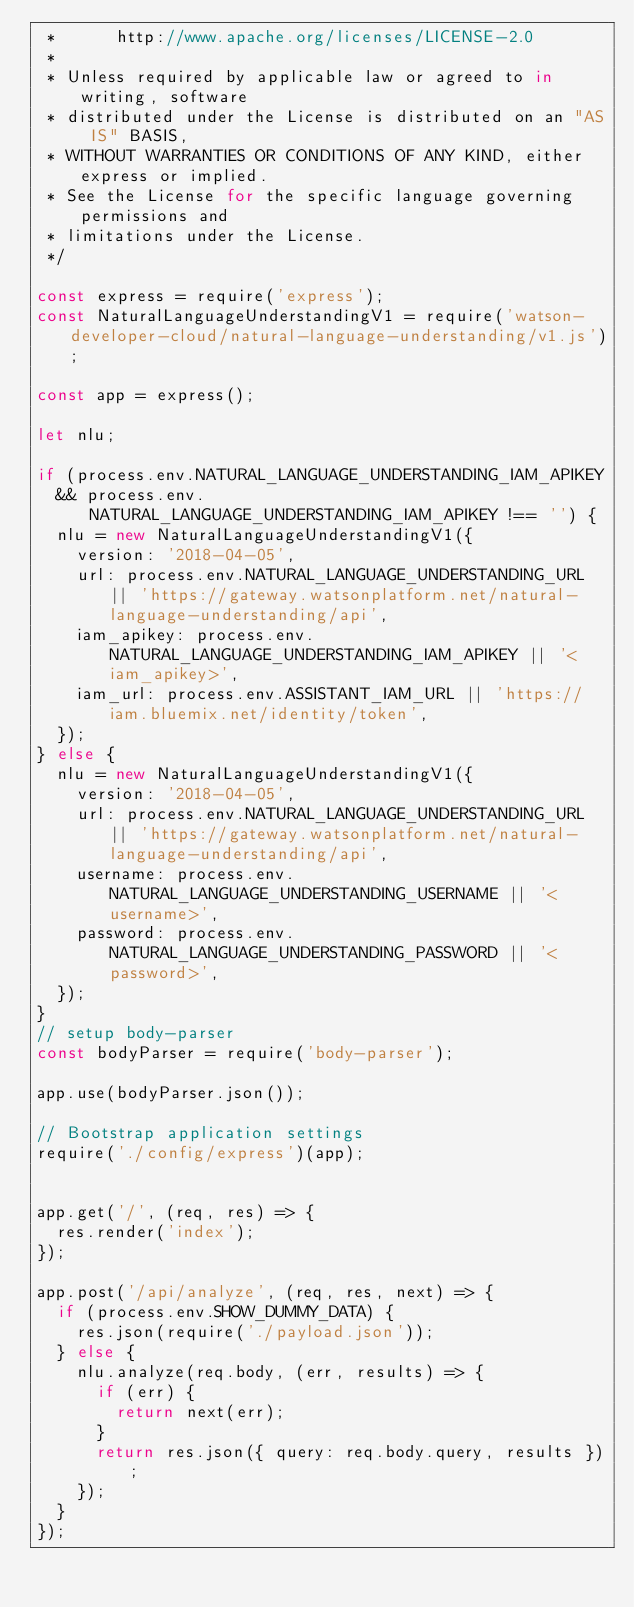Convert code to text. <code><loc_0><loc_0><loc_500><loc_500><_JavaScript_> *      http://www.apache.org/licenses/LICENSE-2.0
 *
 * Unless required by applicable law or agreed to in writing, software
 * distributed under the License is distributed on an "AS IS" BASIS,
 * WITHOUT WARRANTIES OR CONDITIONS OF ANY KIND, either express or implied.
 * See the License for the specific language governing permissions and
 * limitations under the License.
 */

const express = require('express');
const NaturalLanguageUnderstandingV1 = require('watson-developer-cloud/natural-language-understanding/v1.js');

const app = express();

let nlu;

if (process.env.NATURAL_LANGUAGE_UNDERSTANDING_IAM_APIKEY
  && process.env.NATURAL_LANGUAGE_UNDERSTANDING_IAM_APIKEY !== '') {
  nlu = new NaturalLanguageUnderstandingV1({
    version: '2018-04-05',
    url: process.env.NATURAL_LANGUAGE_UNDERSTANDING_URL || 'https://gateway.watsonplatform.net/natural-language-understanding/api',
    iam_apikey: process.env.NATURAL_LANGUAGE_UNDERSTANDING_IAM_APIKEY || '<iam_apikey>',
    iam_url: process.env.ASSISTANT_IAM_URL || 'https://iam.bluemix.net/identity/token',
  });
} else {
  nlu = new NaturalLanguageUnderstandingV1({
    version: '2018-04-05',
    url: process.env.NATURAL_LANGUAGE_UNDERSTANDING_URL || 'https://gateway.watsonplatform.net/natural-language-understanding/api',
    username: process.env.NATURAL_LANGUAGE_UNDERSTANDING_USERNAME || '<username>',
    password: process.env.NATURAL_LANGUAGE_UNDERSTANDING_PASSWORD || '<password>',
  });
}
// setup body-parser
const bodyParser = require('body-parser');

app.use(bodyParser.json());

// Bootstrap application settings
require('./config/express')(app);


app.get('/', (req, res) => {
  res.render('index');
});

app.post('/api/analyze', (req, res, next) => {
  if (process.env.SHOW_DUMMY_DATA) {
    res.json(require('./payload.json'));
  } else {
    nlu.analyze(req.body, (err, results) => {
      if (err) {
        return next(err);
      }
      return res.json({ query: req.body.query, results });
    });
  }
});
</code> 